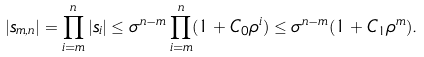Convert formula to latex. <formula><loc_0><loc_0><loc_500><loc_500>| s _ { m , n } | = \prod _ { i = m } ^ { n } | s _ { i } | \leq \sigma ^ { n - m } \prod _ { i = m } ^ { n } ( 1 + C _ { 0 } \rho ^ { i } ) \leq \sigma ^ { n - m } ( 1 + C _ { 1 } \rho ^ { m } ) .</formula> 